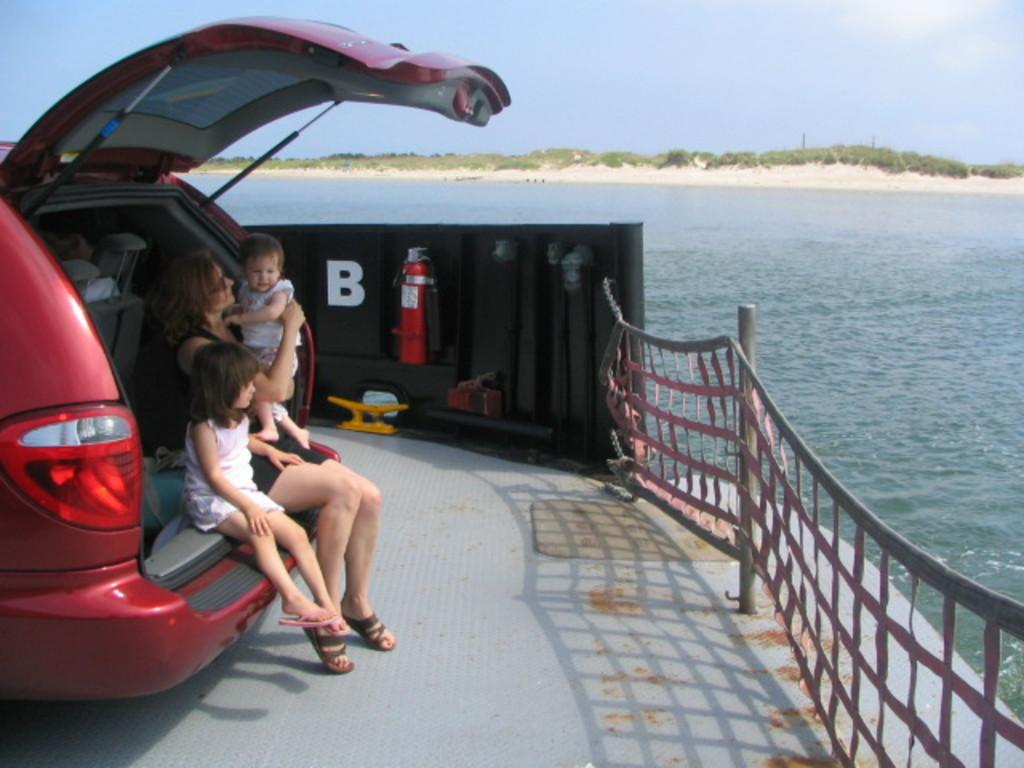Who is present in the image? There is a woman and two children in the image. What are they standing near? They are standing near the back side of a car. What safety item can be seen in the image? There is an emergency cylinder in the image. What can be seen in the background of the image? There are trees, water, and the sky visible in the background of the image. What type of dinner is being served in the image? There is no dinner being served in the image; it features a woman and two children standing near a car with an emergency cylinder present. Can you see any icicles hanging from the trees in the image? There are no icicles visible in the image; it is set in an outdoor environment with trees, water, and the sky visible in the background. 